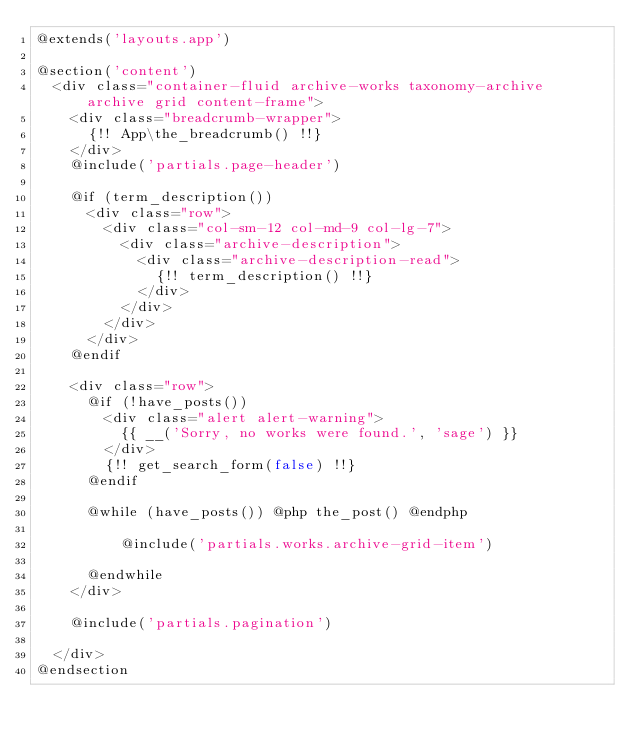Convert code to text. <code><loc_0><loc_0><loc_500><loc_500><_PHP_>@extends('layouts.app')

@section('content')
  <div class="container-fluid archive-works taxonomy-archive archive grid content-frame">
    <div class="breadcrumb-wrapper">
      {!! App\the_breadcrumb() !!}
    </div>
    @include('partials.page-header')

    @if (term_description())
      <div class="row">
        <div class="col-sm-12 col-md-9 col-lg-7">
          <div class="archive-description">
            <div class="archive-description-read">
              {!! term_description() !!}
            </div>
          </div>
        </div>
      </div>
    @endif

    <div class="row">
      @if (!have_posts())
        <div class="alert alert-warning">
          {{ __('Sorry, no works were found.', 'sage') }}
        </div>
        {!! get_search_form(false) !!}
      @endif

      @while (have_posts()) @php the_post() @endphp

          @include('partials.works.archive-grid-item')

      @endwhile
    </div>

    @include('partials.pagination')

  </div>
@endsection
</code> 